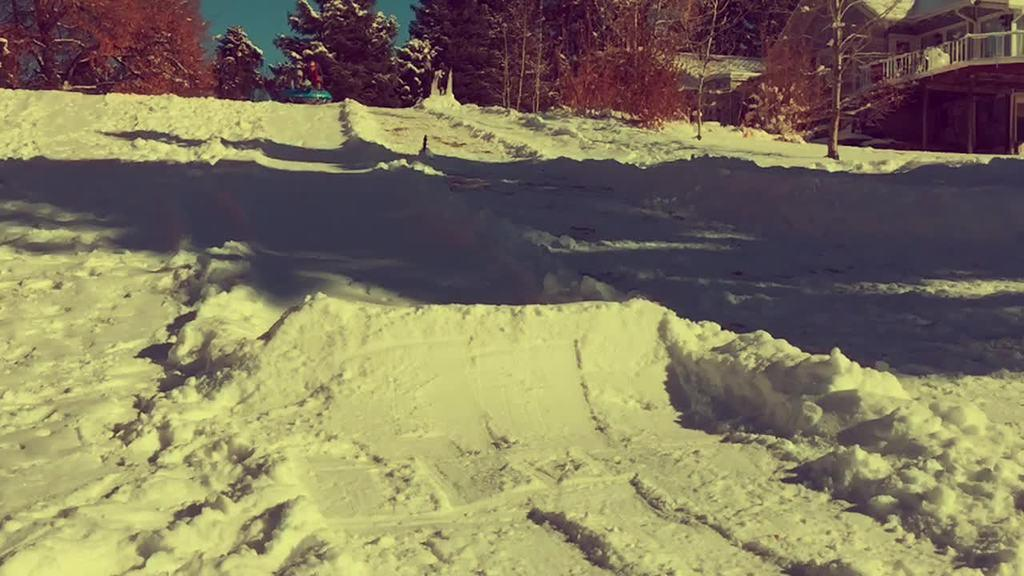What is the condition of the ground in the image? The ground is covered with snow. What type of structures can be seen in the image? There are houses in the image. What type of vegetation is present in the image? There are trees in the image. What is visible in the background of the image? The sky is visible in the image. How many family members are visible in the image? There is no family present in the image; it only shows the snow-covered ground, houses, trees, and the sky. What is the level of wealth depicted in the image? There is no indication of wealth in the image; it only shows the snow-covered ground, houses, trees, and the sky. 